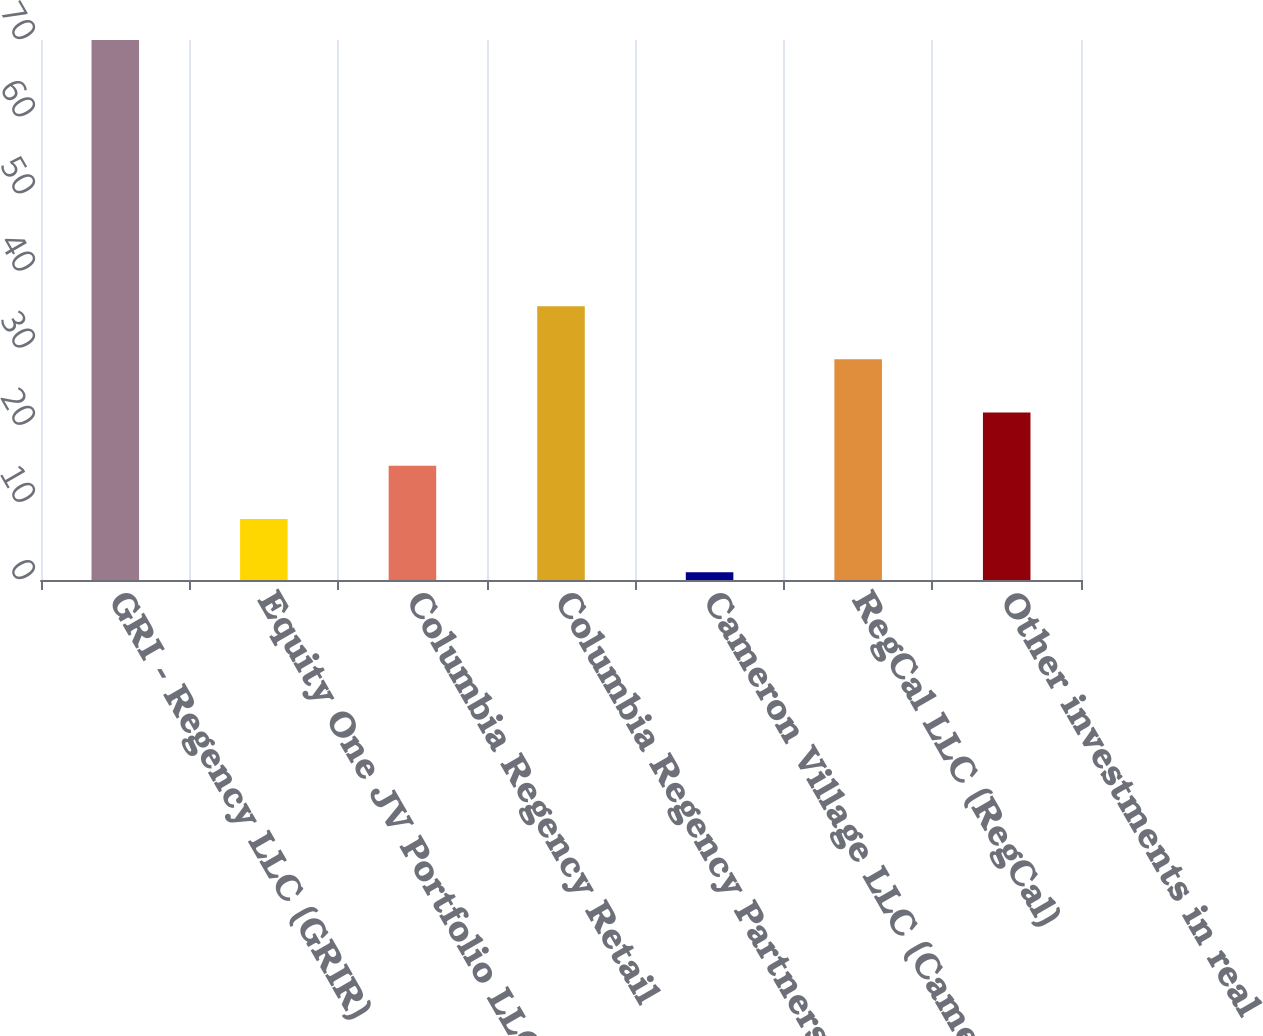Convert chart. <chart><loc_0><loc_0><loc_500><loc_500><bar_chart><fcel>GRI - Regency LLC (GRIR)<fcel>Equity One JV Portfolio LLC<fcel>Columbia Regency Retail<fcel>Columbia Regency Partners II<fcel>Cameron Village LLC (Cameron)<fcel>RegCal LLC (RegCal)<fcel>Other investments in real<nl><fcel>70<fcel>7.9<fcel>14.8<fcel>35.5<fcel>1<fcel>28.6<fcel>21.7<nl></chart> 